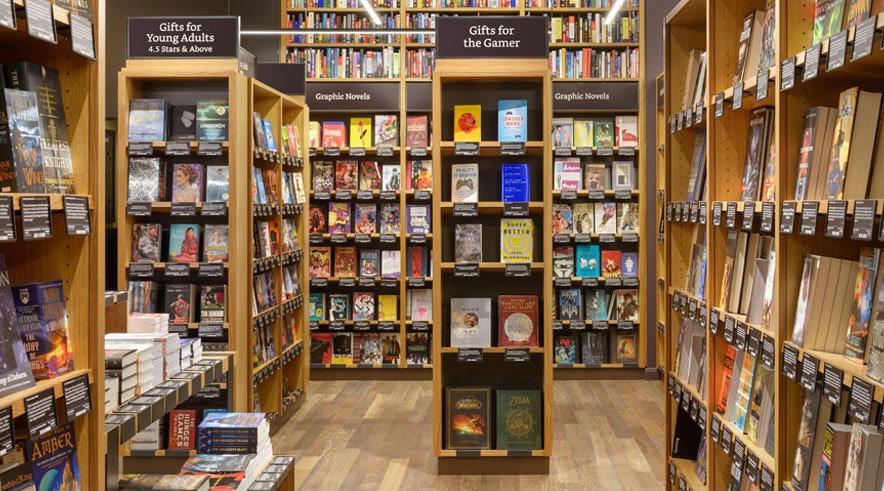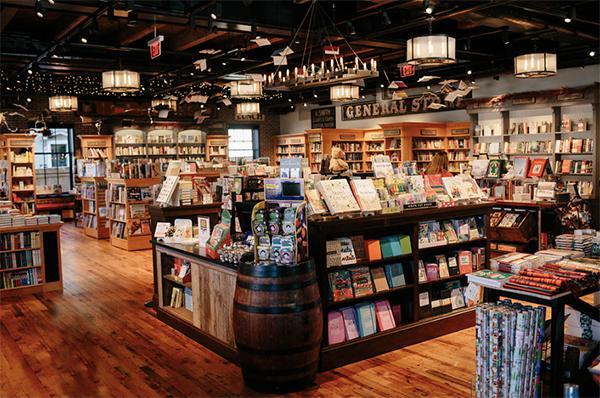The first image is the image on the left, the second image is the image on the right. For the images shown, is this caption "There is at least one person in the image on the left." true? Answer yes or no. No. 